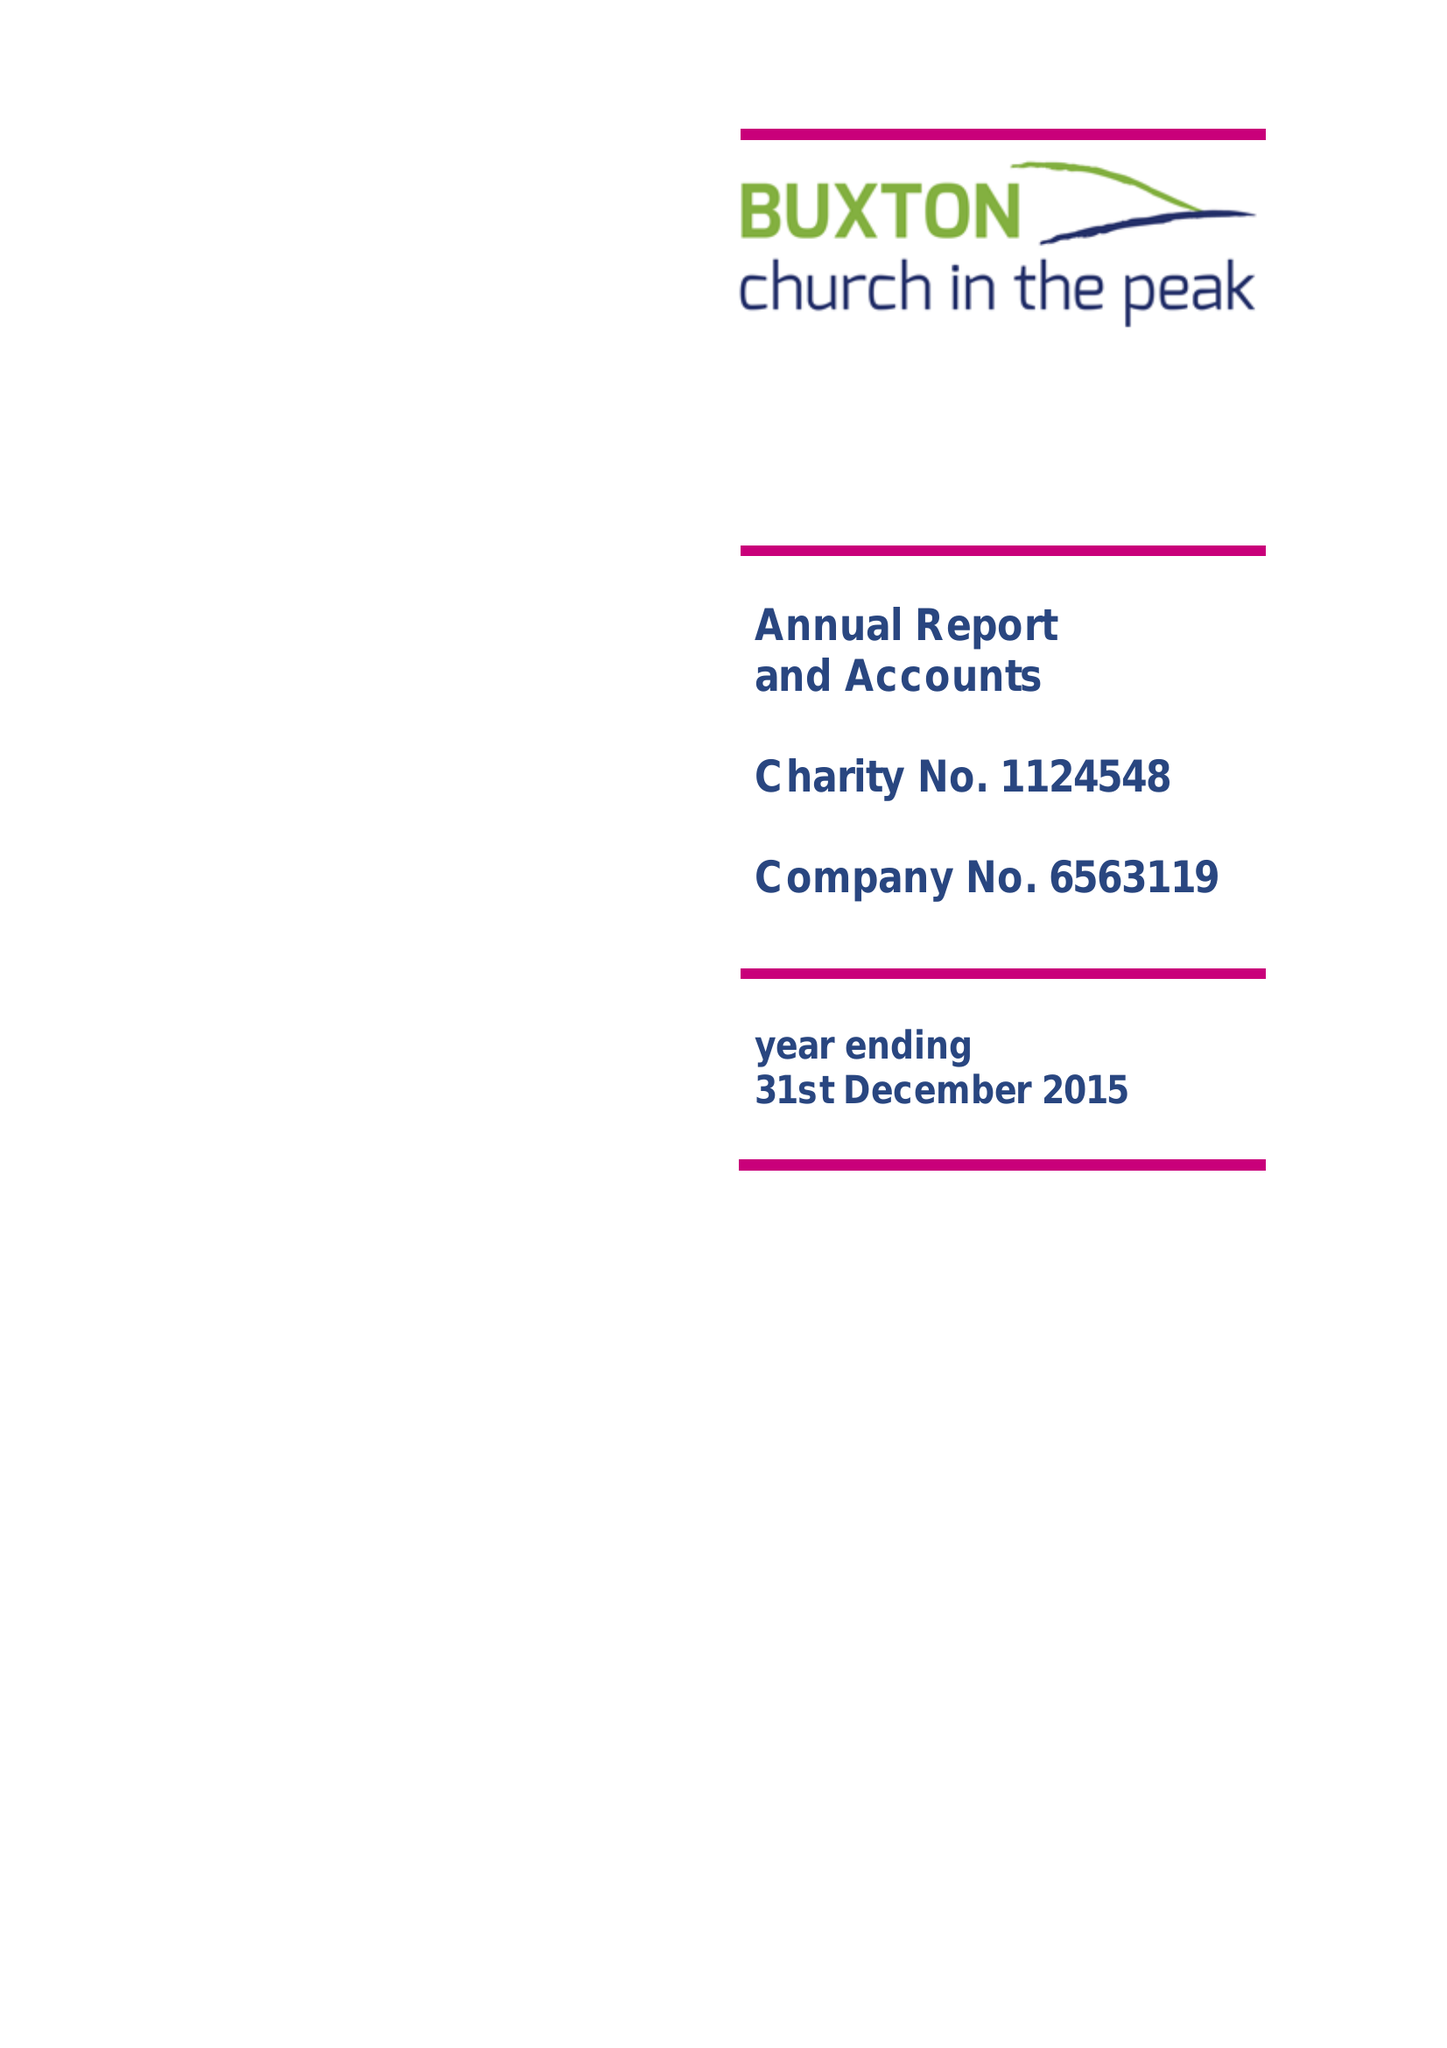What is the value for the income_annually_in_british_pounds?
Answer the question using a single word or phrase. 108101.00 